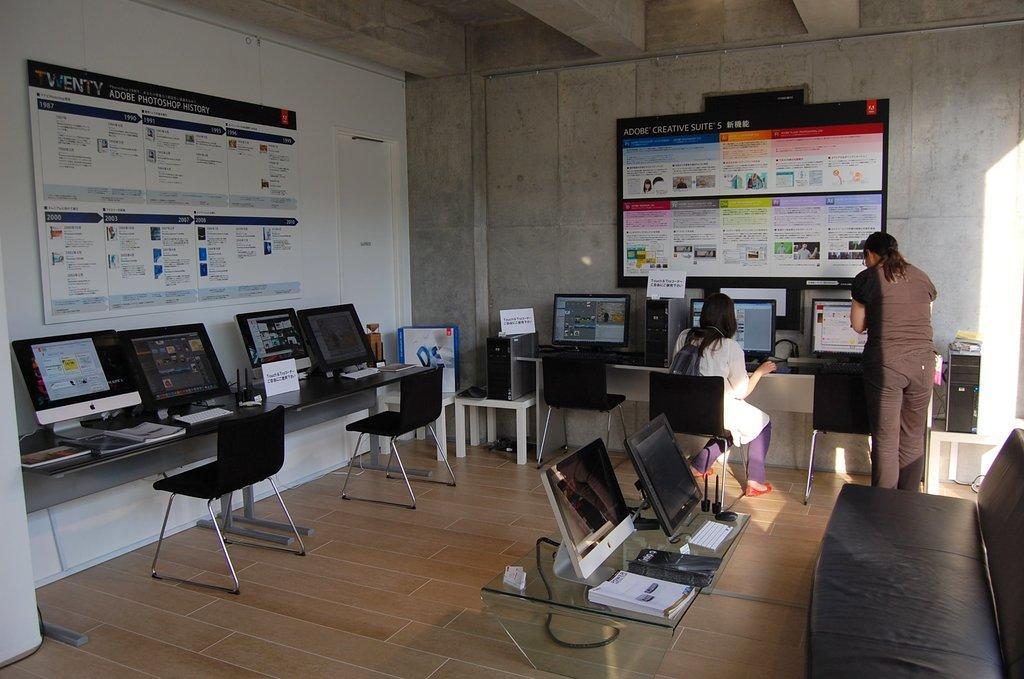How would you summarize this image in a sentence or two? In this picture we can see the inside view of a room. These are the monitors and there are chairs. Here we can see a woman sitting on the chair. And this is floor. On the background there is a wall and these are the boards. Here we can see a person who is standing on the floor. 